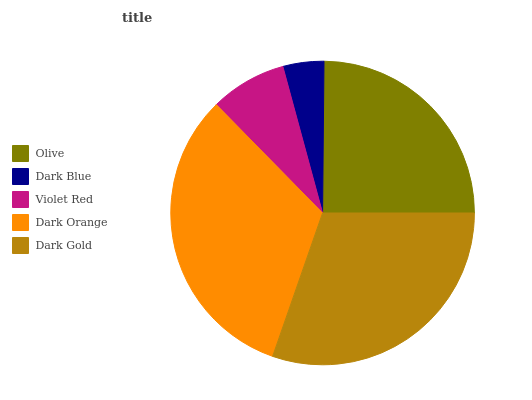Is Dark Blue the minimum?
Answer yes or no. Yes. Is Dark Orange the maximum?
Answer yes or no. Yes. Is Violet Red the minimum?
Answer yes or no. No. Is Violet Red the maximum?
Answer yes or no. No. Is Violet Red greater than Dark Blue?
Answer yes or no. Yes. Is Dark Blue less than Violet Red?
Answer yes or no. Yes. Is Dark Blue greater than Violet Red?
Answer yes or no. No. Is Violet Red less than Dark Blue?
Answer yes or no. No. Is Olive the high median?
Answer yes or no. Yes. Is Olive the low median?
Answer yes or no. Yes. Is Dark Orange the high median?
Answer yes or no. No. Is Dark Blue the low median?
Answer yes or no. No. 